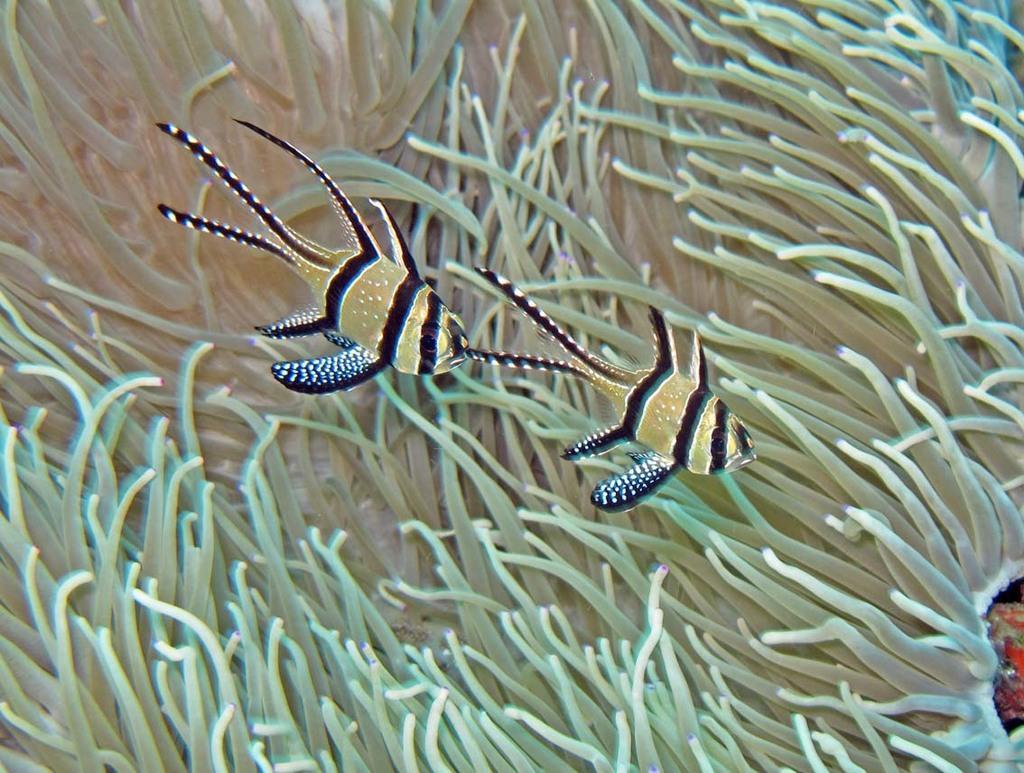Describe this image in one or two sentences. In this image I can see few fishes, they are in black, brown and white color, and I can see plants in green color. 